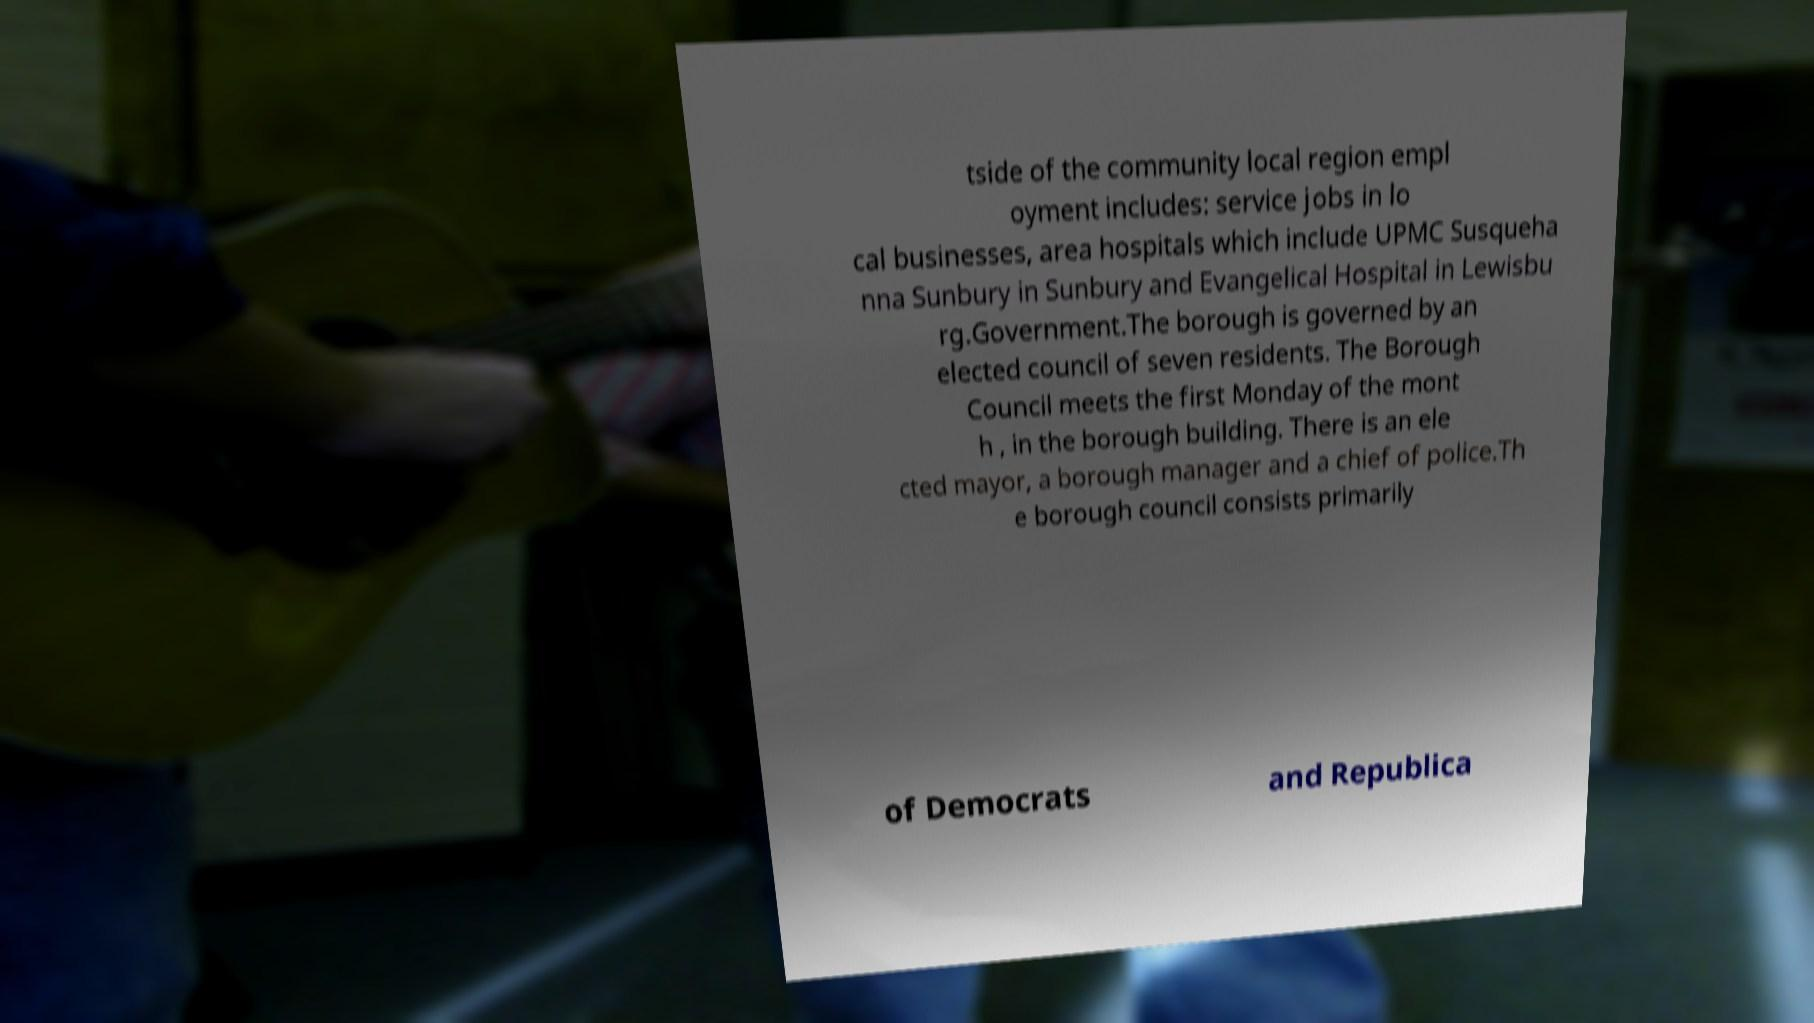Please read and relay the text visible in this image. What does it say? tside of the community local region empl oyment includes: service jobs in lo cal businesses, area hospitals which include UPMC Susqueha nna Sunbury in Sunbury and Evangelical Hospital in Lewisbu rg.Government.The borough is governed by an elected council of seven residents. The Borough Council meets the first Monday of the mont h , in the borough building. There is an ele cted mayor, a borough manager and a chief of police.Th e borough council consists primarily of Democrats and Republica 